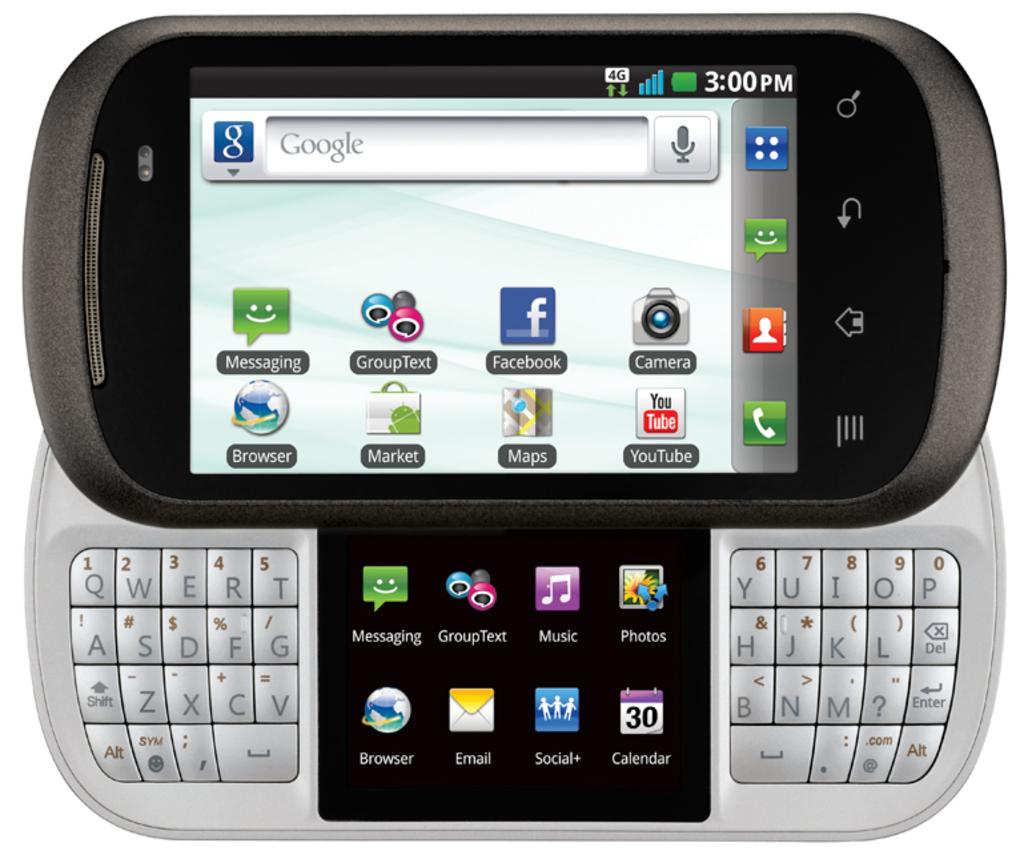How many apps are on this page excluding market?
Offer a very short reply. 7. 